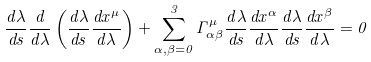<formula> <loc_0><loc_0><loc_500><loc_500>\frac { d \lambda } { d s } \frac { d } { d \lambda } \left ( \frac { d \lambda } { d s } \frac { d x ^ { \mu } } { d \lambda } \right ) + \sum _ { \alpha , \beta = 0 } ^ { 3 } \Gamma _ { \alpha \beta } ^ { \mu } \frac { d \lambda } { d s } \frac { d x ^ { \alpha } } { d \lambda } \frac { d \lambda } { d s } \frac { d x ^ { \beta } } { d \lambda } = 0</formula> 